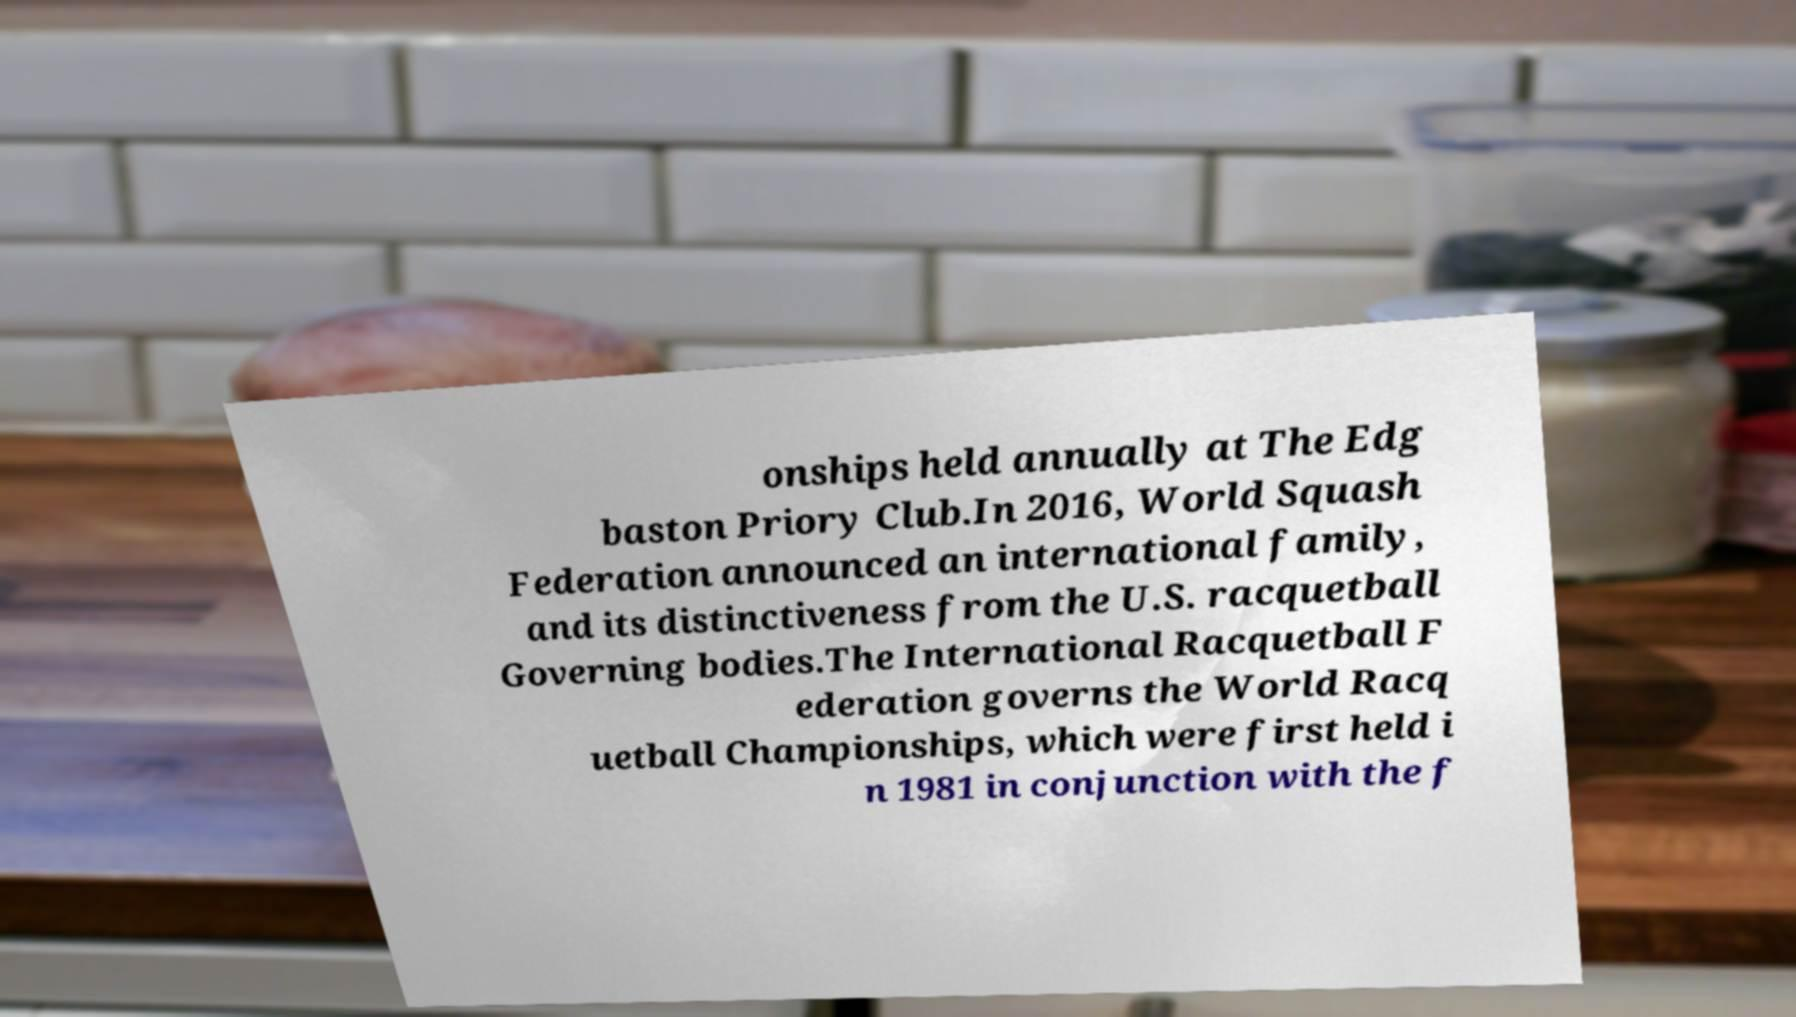Could you extract and type out the text from this image? onships held annually at The Edg baston Priory Club.In 2016, World Squash Federation announced an international family, and its distinctiveness from the U.S. racquetball Governing bodies.The International Racquetball F ederation governs the World Racq uetball Championships, which were first held i n 1981 in conjunction with the f 